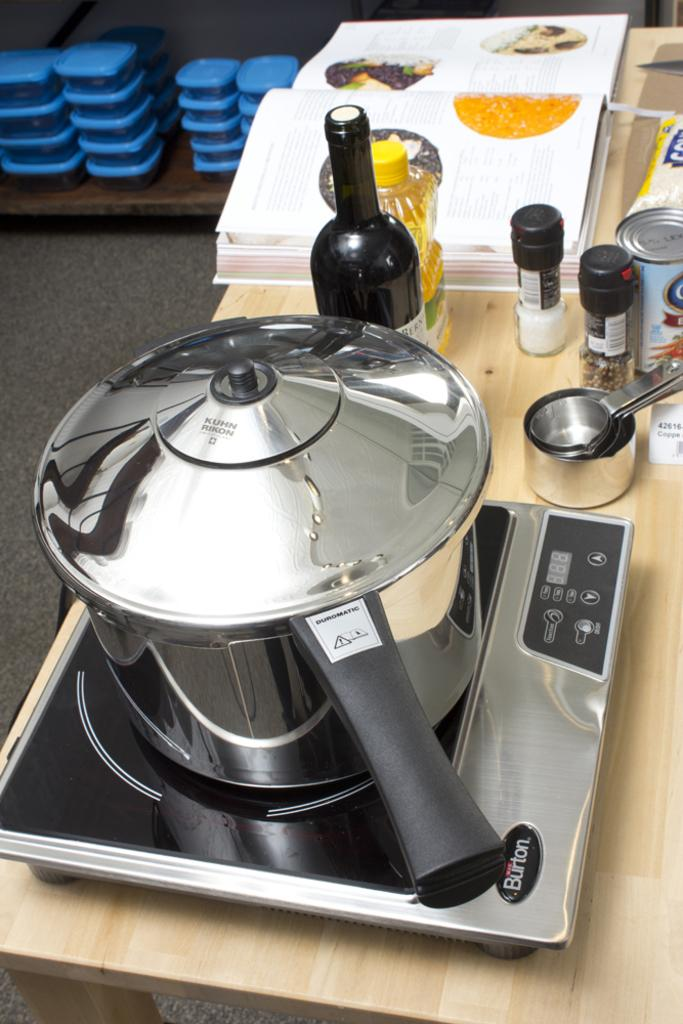<image>
Present a compact description of the photo's key features. The pot sitting on the stove is made by Kuhn Rikon. 